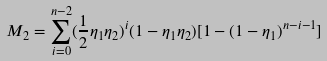<formula> <loc_0><loc_0><loc_500><loc_500>M _ { 2 } = \sum _ { i = 0 } ^ { n - 2 } ( \frac { 1 } { 2 } \eta _ { 1 } \eta _ { 2 } ) ^ { i } ( 1 - \eta _ { 1 } \eta _ { 2 } ) [ 1 - ( 1 - \eta _ { 1 } ) ^ { n - i - 1 } ]</formula> 